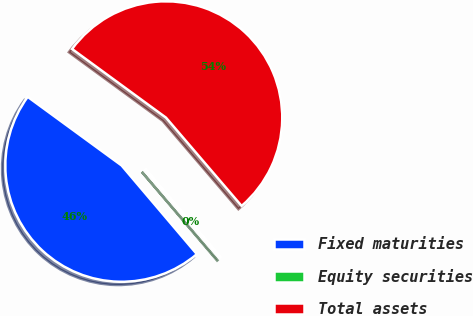Convert chart. <chart><loc_0><loc_0><loc_500><loc_500><pie_chart><fcel>Fixed maturities<fcel>Equity securities<fcel>Total assets<nl><fcel>46.25%<fcel>0.07%<fcel>53.68%<nl></chart> 